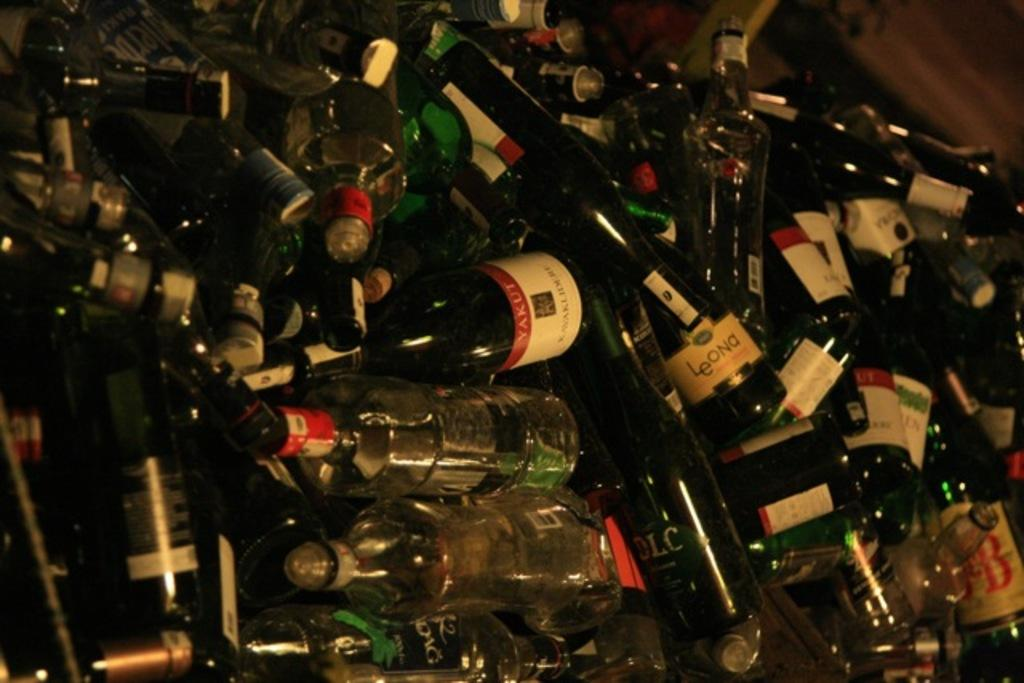<image>
Present a compact description of the photo's key features. A huge pile of bottles, one of which says LeOna. 